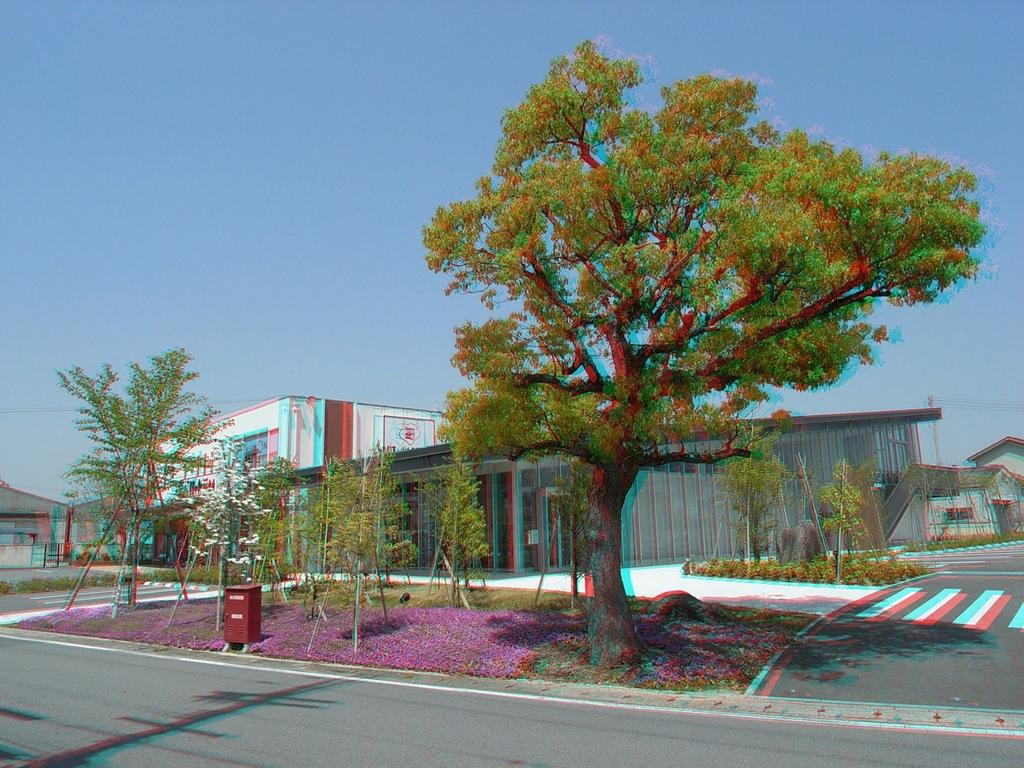What type of structures can be seen in the image? There are buildings in the image. What type of vegetation is present in the image? There are trees in the image. What color is the sky in the image? The sky is blue in the image. What type of trouble can be seen in the image? There is no indication of trouble in the image; it features buildings, trees, and a blue sky. What type of company is depicted in the image? There is no company depicted in the image; it features buildings, trees, and a blue sky. 